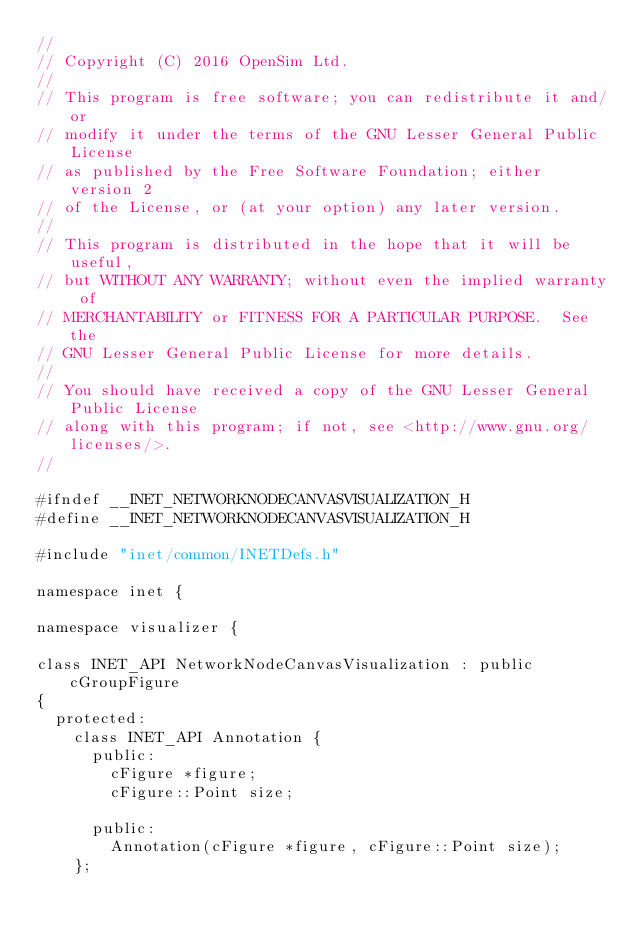<code> <loc_0><loc_0><loc_500><loc_500><_C_>//
// Copyright (C) 2016 OpenSim Ltd.
//
// This program is free software; you can redistribute it and/or
// modify it under the terms of the GNU Lesser General Public License
// as published by the Free Software Foundation; either version 2
// of the License, or (at your option) any later version.
//
// This program is distributed in the hope that it will be useful,
// but WITHOUT ANY WARRANTY; without even the implied warranty of
// MERCHANTABILITY or FITNESS FOR A PARTICULAR PURPOSE.  See the
// GNU Lesser General Public License for more details.
//
// You should have received a copy of the GNU Lesser General Public License
// along with this program; if not, see <http://www.gnu.org/licenses/>.
//

#ifndef __INET_NETWORKNODECANVASVISUALIZATION_H
#define __INET_NETWORKNODECANVASVISUALIZATION_H

#include "inet/common/INETDefs.h"

namespace inet {

namespace visualizer {

class INET_API NetworkNodeCanvasVisualization : public cGroupFigure
{
  protected:
    class INET_API Annotation {
      public:
        cFigure *figure;
        cFigure::Point size;

      public:
        Annotation(cFigure *figure, cFigure::Point size);
    };
</code> 